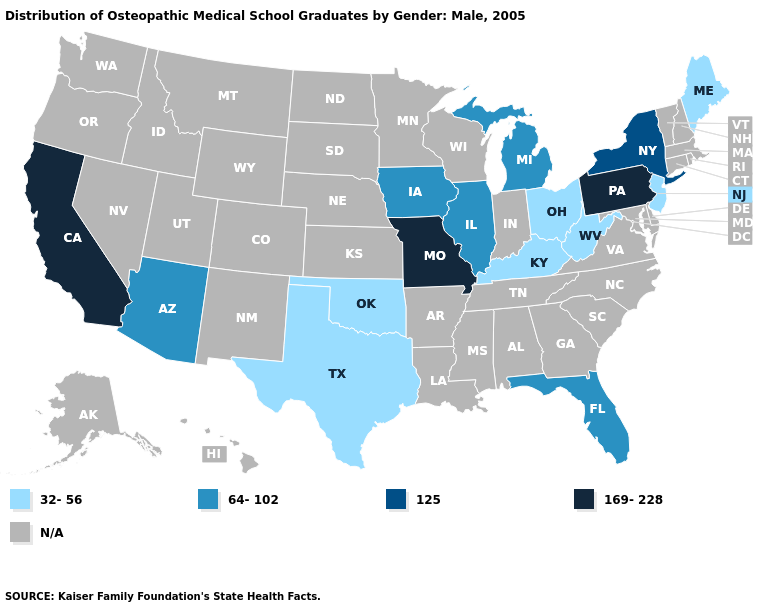What is the value of Alabama?
Be succinct. N/A. Does the first symbol in the legend represent the smallest category?
Quick response, please. Yes. Name the states that have a value in the range 32-56?
Be succinct. Kentucky, Maine, New Jersey, Ohio, Oklahoma, Texas, West Virginia. Does the first symbol in the legend represent the smallest category?
Be succinct. Yes. Name the states that have a value in the range 169-228?
Concise answer only. California, Missouri, Pennsylvania. Name the states that have a value in the range 32-56?
Answer briefly. Kentucky, Maine, New Jersey, Ohio, Oklahoma, Texas, West Virginia. Which states have the lowest value in the USA?
Concise answer only. Kentucky, Maine, New Jersey, Ohio, Oklahoma, Texas, West Virginia. What is the value of Missouri?
Answer briefly. 169-228. Among the states that border Delaware , which have the highest value?
Give a very brief answer. Pennsylvania. Does the first symbol in the legend represent the smallest category?
Quick response, please. Yes. What is the value of Georgia?
Give a very brief answer. N/A. What is the value of Louisiana?
Keep it brief. N/A. What is the value of New Jersey?
Write a very short answer. 32-56. What is the lowest value in the USA?
Quick response, please. 32-56. 